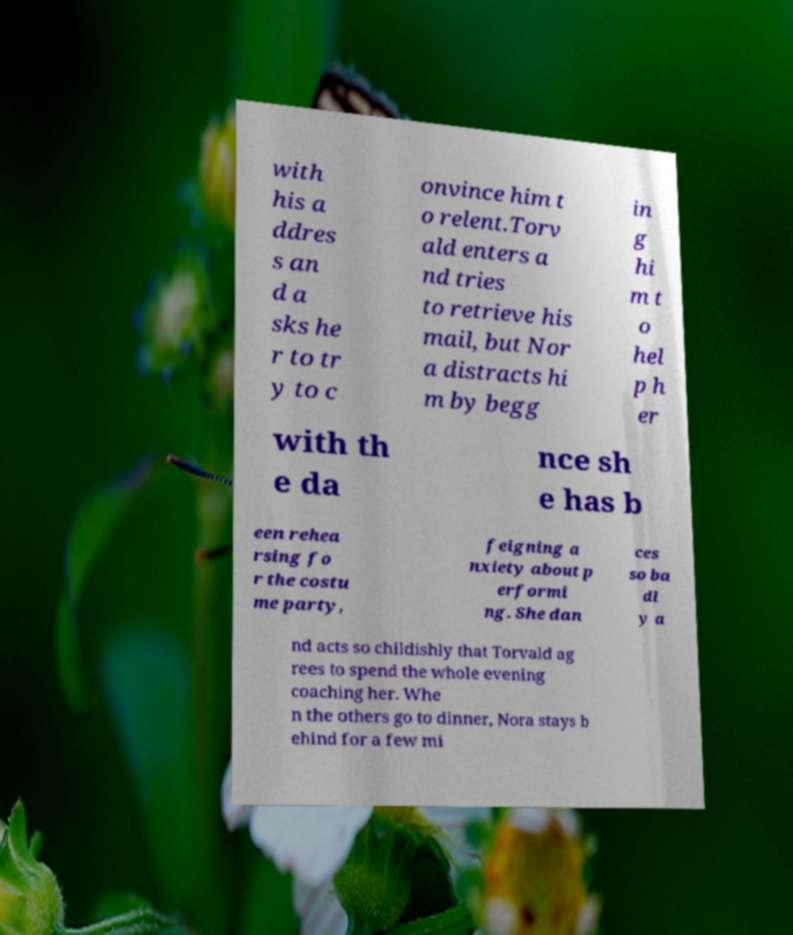For documentation purposes, I need the text within this image transcribed. Could you provide that? with his a ddres s an d a sks he r to tr y to c onvince him t o relent.Torv ald enters a nd tries to retrieve his mail, but Nor a distracts hi m by begg in g hi m t o hel p h er with th e da nce sh e has b een rehea rsing fo r the costu me party, feigning a nxiety about p erformi ng. She dan ces so ba dl y a nd acts so childishly that Torvald ag rees to spend the whole evening coaching her. Whe n the others go to dinner, Nora stays b ehind for a few mi 